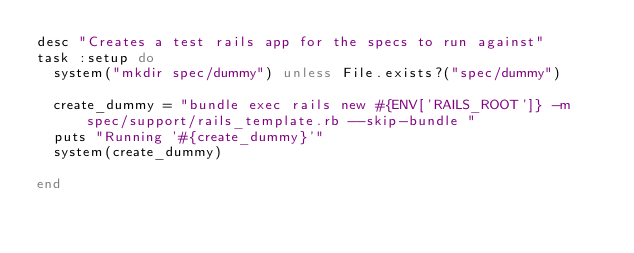<code> <loc_0><loc_0><loc_500><loc_500><_Ruby_>desc "Creates a test rails app for the specs to run against"
task :setup do
  system("mkdir spec/dummy") unless File.exists?("spec/dummy")

  create_dummy = "bundle exec rails new #{ENV['RAILS_ROOT']} -m spec/support/rails_template.rb --skip-bundle "
  puts "Running '#{create_dummy}'"
  system(create_dummy)

end
</code> 